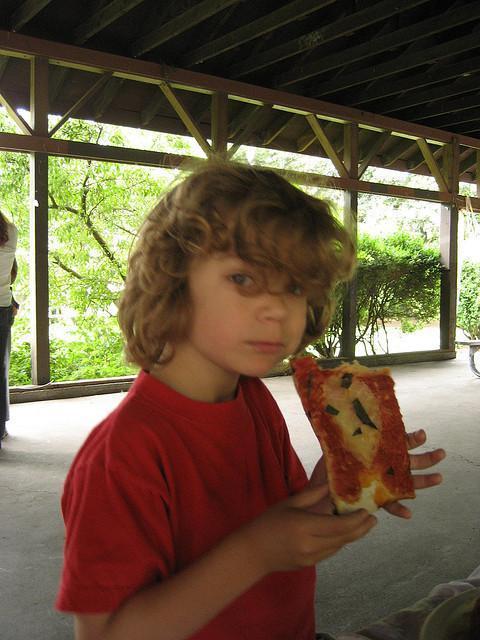How many people are wearing stripes?
Give a very brief answer. 0. How many people can be seen?
Give a very brief answer. 2. How many clocks are on the building?
Give a very brief answer. 0. 